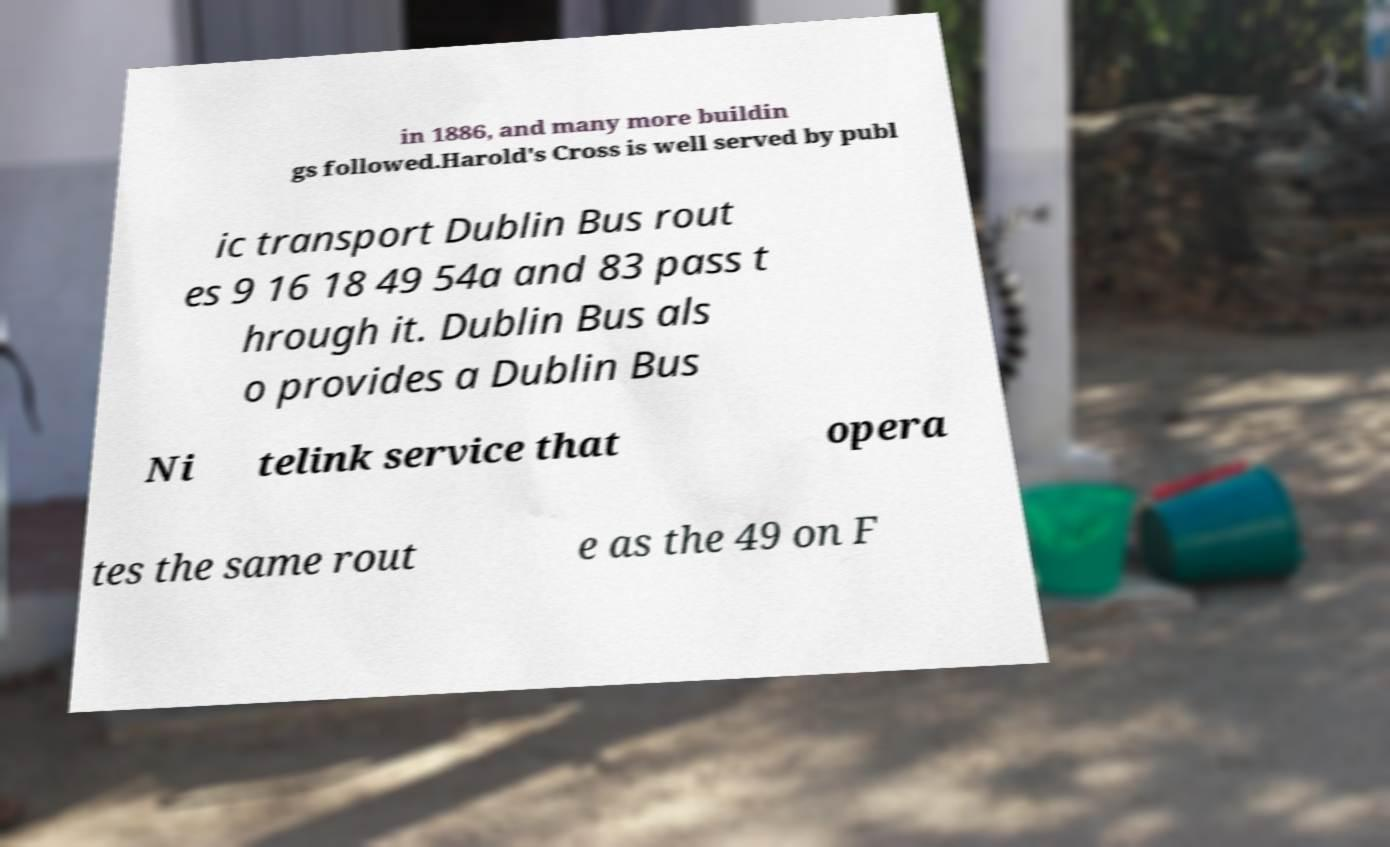What messages or text are displayed in this image? I need them in a readable, typed format. in 1886, and many more buildin gs followed.Harold's Cross is well served by publ ic transport Dublin Bus rout es 9 16 18 49 54a and 83 pass t hrough it. Dublin Bus als o provides a Dublin Bus Ni telink service that opera tes the same rout e as the 49 on F 